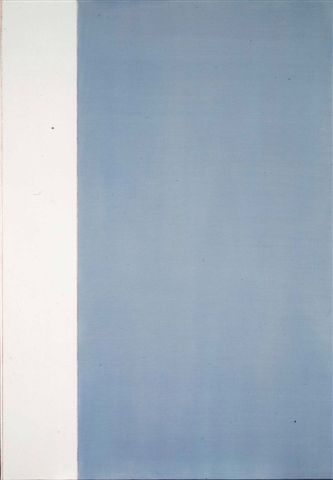Can you elaborate on the emotions that this artwork evokes? This piece of abstract art evokes a mix of emotions. The white section might bring feelings of calmness, purity, or emptiness, creating a serene and contemplative atmosphere. On the other hand, the blue section, with its gradient effect, can evoke a sense of depth, tranquility, and introspection. Together, the contrast between the two colors might inspire a feeling of balance, signifying the harmonious coexistence of different emotional states. Why do artists use such minimalistic styles? What could they be trying to convey? Minimalistic art often seeks to strip down elements to their most fundamental aspects to emphasize simplicity, focus, and clarity. Artists who adopt this style may aim to convey purity, essential truths, or to provoke thought about the relationships and contrasts between the few elements present. By reducing distractions and focusing on essential forms and colors, minimalistic art invites viewers to engage more deeply with the essence of the work, often encouraging personal interpretation and introspection. 